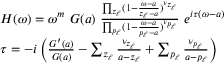<formula> <loc_0><loc_0><loc_500><loc_500>\begin{array} { r } { \begin{array} { r l } & { H ( \omega ) = \omega ^ { m } G ( a ) \frac { \prod _ { z _ { \ell } } ( 1 - \frac { \omega - a } { z _ { \ell } - a } ) ^ { \nu _ { z _ { \ell } } } } { \prod _ { p _ { \ell } } ( 1 - \frac { \omega - a } { p _ { \ell } - a } ) ^ { \nu _ { p _ { \ell } } } } e ^ { i \tau ( \omega - a ) } } \\ & { \tau = - i \left ( \frac { G ^ { \prime } ( a ) } { G ( a ) } - \sum _ { z _ { \ell } } \frac { \nu _ { z _ { \ell } } } { a - z _ { \ell } } + \sum _ { p _ { \ell } } \frac { \nu _ { p _ { \ell } } } { a - p _ { \ell } } \right ) } \end{array} } \end{array}</formula> 